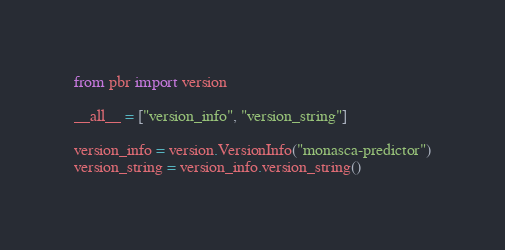Convert code to text. <code><loc_0><loc_0><loc_500><loc_500><_Python_>from pbr import version

__all__ = ["version_info", "version_string"]

version_info = version.VersionInfo("monasca-predictor")
version_string = version_info.version_string()
</code> 